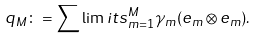<formula> <loc_0><loc_0><loc_500><loc_500>q _ { M } \colon = \sum \lim i t s _ { m = 1 } ^ { M } \gamma _ { m } ( e _ { m } \otimes e _ { m } ) .</formula> 